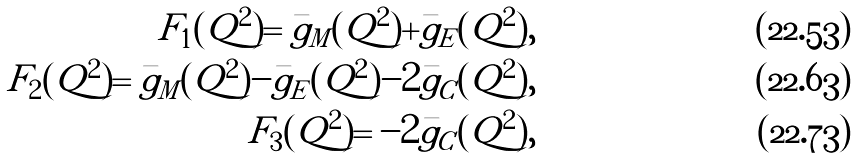Convert formula to latex. <formula><loc_0><loc_0><loc_500><loc_500>F _ { 1 } ( Q ^ { 2 } ) = \bar { g } _ { M } ( Q ^ { 2 } ) + \bar { g } _ { E } ( Q ^ { 2 } ) , \\ F _ { 2 } ( Q ^ { 2 } ) = \bar { g } _ { M } ( Q ^ { 2 } ) - \bar { g } _ { E } ( Q ^ { 2 } ) - 2 \bar { g } _ { C } ( Q ^ { 2 } ) , \\ F _ { 3 } ( Q ^ { 2 } ) = - 2 \bar { g } _ { C } ( Q ^ { 2 } ) ,</formula> 